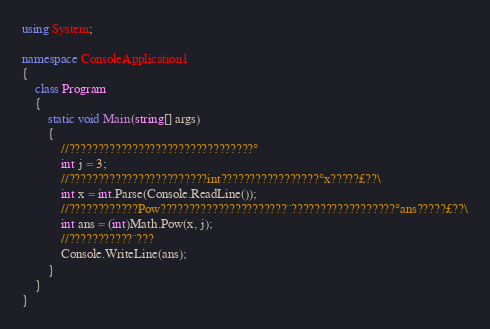<code> <loc_0><loc_0><loc_500><loc_500><_C#_>using System;

namespace ConsoleApplication1
{
    class Program
    {
        static void Main(string[] args)
        {
            //????????????????????????????????°
            int j = 3;
            //????????????????????????int?????????????????°x?????£??\
            int x = int.Parse(Console.ReadLine());
            //????????????Pow??????????????????????¨??????????????????°ans?????£??\
            int ans = (int)Math.Pow(x, j);
            //???????????¨???
            Console.WriteLine(ans);
        }
    }
}</code> 